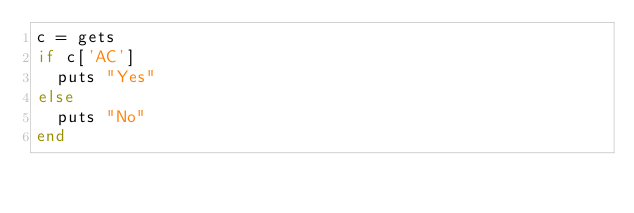<code> <loc_0><loc_0><loc_500><loc_500><_Ruby_>c = gets
if c['AC']
  puts "Yes"
else
  puts "No"
end</code> 